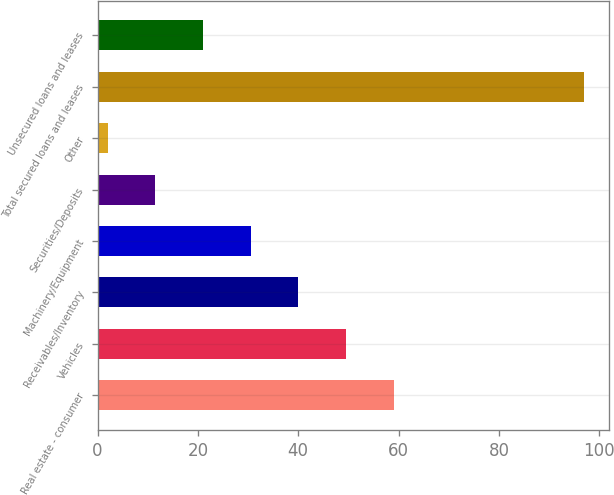Convert chart. <chart><loc_0><loc_0><loc_500><loc_500><bar_chart><fcel>Real estate - consumer<fcel>Vehicles<fcel>Receivables/Inventory<fcel>Machinery/Equipment<fcel>Securities/Deposits<fcel>Other<fcel>Total secured loans and leases<fcel>Unsecured loans and leases<nl><fcel>59<fcel>49.5<fcel>40<fcel>30.5<fcel>11.5<fcel>2<fcel>97<fcel>21<nl></chart> 